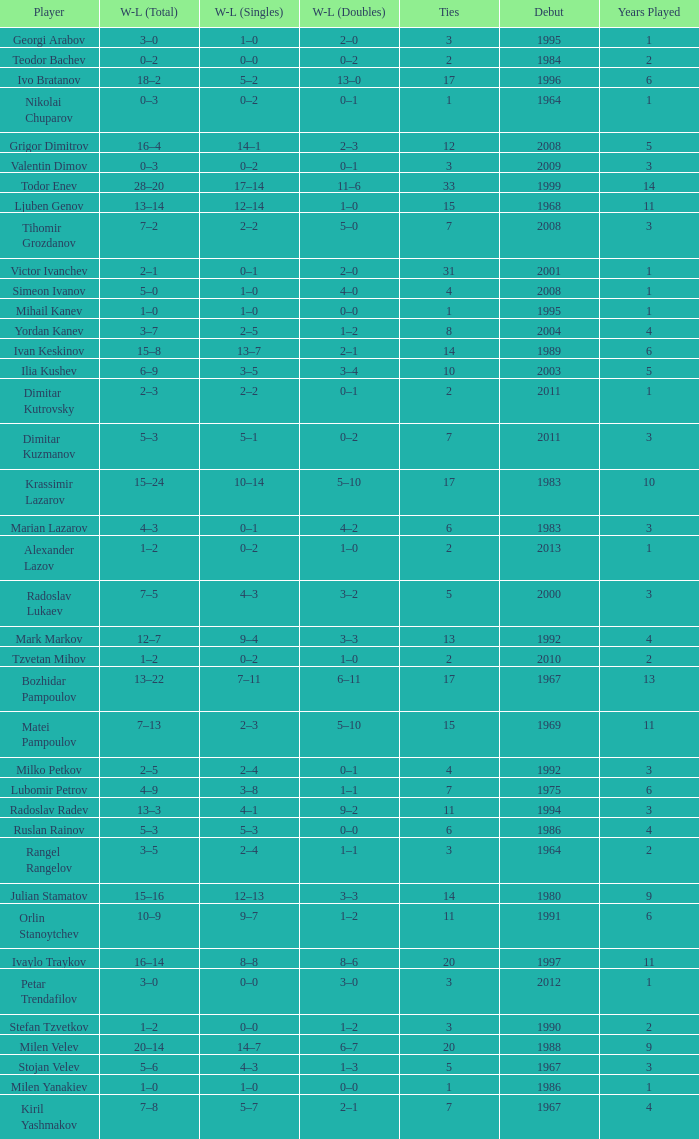Share information on the wl doubles that had an initial appearance in 199 11–6. 